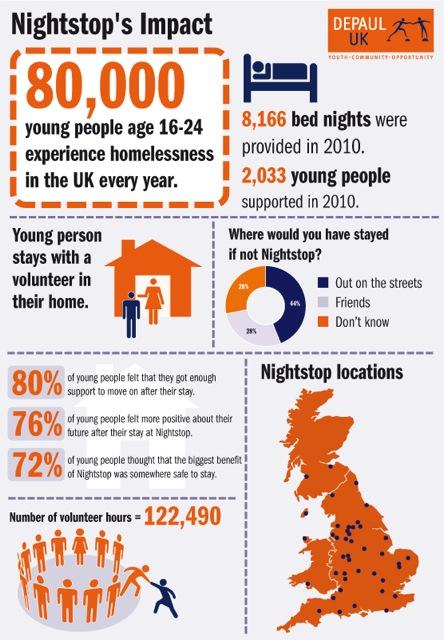Specify some key components in this picture. Nightstop provides a vital service in preventing people from having to stay out on the streets if they have nowhere else to go. 